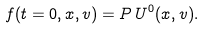<formula> <loc_0><loc_0><loc_500><loc_500>f ( t = 0 , x , v ) = P \, U ^ { 0 } ( x , v ) .</formula> 